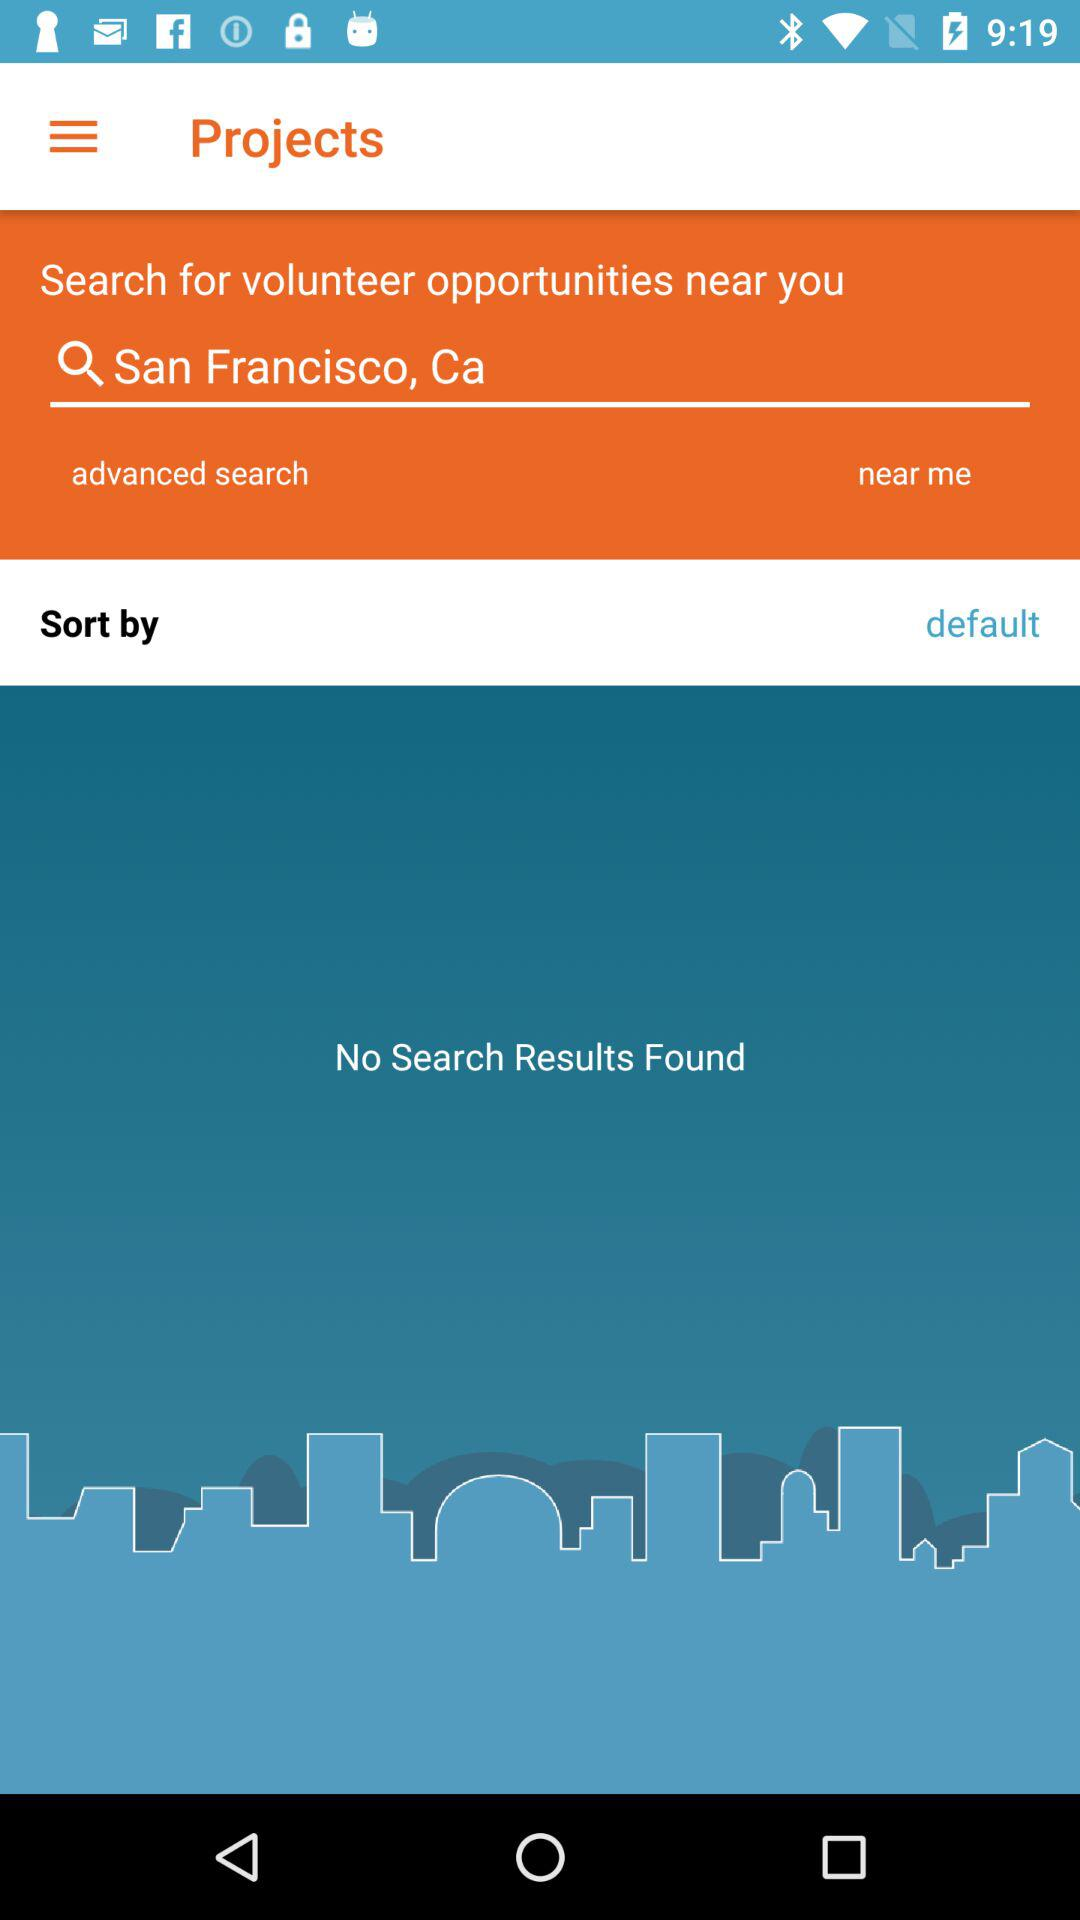How many projects are available?
When the provided information is insufficient, respond with <no answer>. <no answer> 